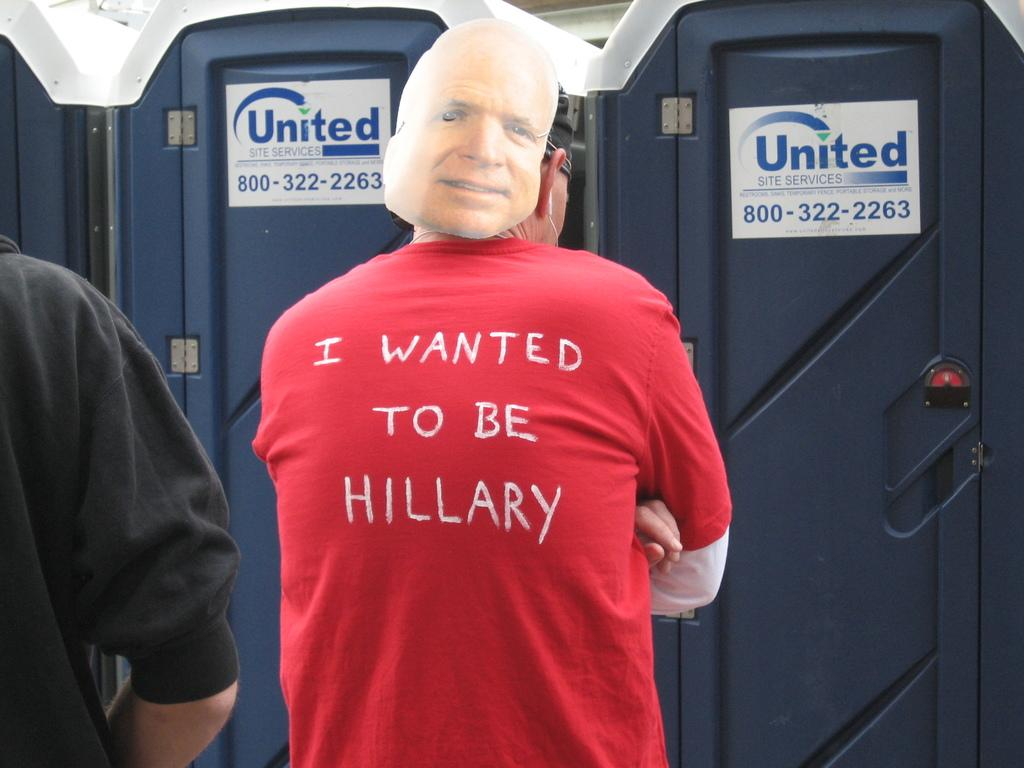<image>
Render a clear and concise summary of the photo. A man wearing a red shirt that says "I wanted to be Hillary" waits in line for the bathroom 